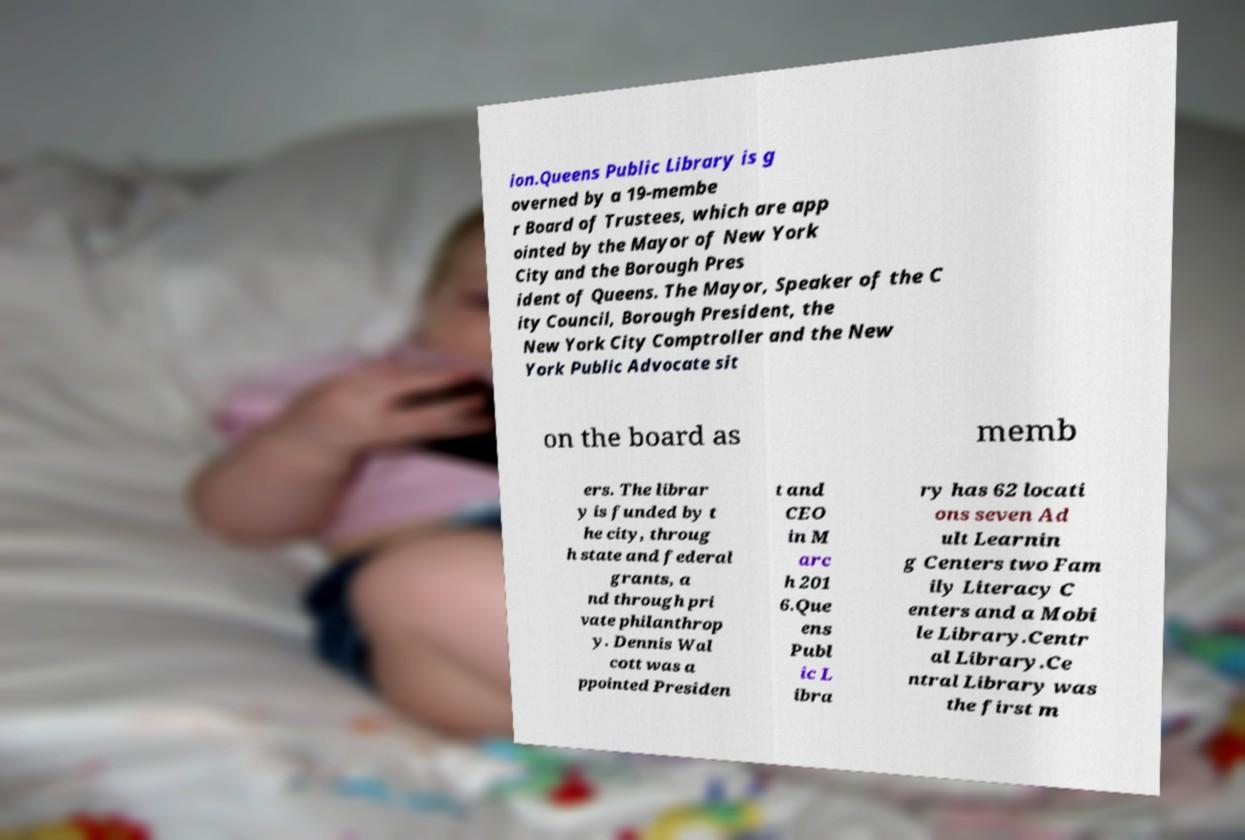Could you extract and type out the text from this image? ion.Queens Public Library is g overned by a 19-membe r Board of Trustees, which are app ointed by the Mayor of New York City and the Borough Pres ident of Queens. The Mayor, Speaker of the C ity Council, Borough President, the New York City Comptroller and the New York Public Advocate sit on the board as memb ers. The librar y is funded by t he city, throug h state and federal grants, a nd through pri vate philanthrop y. Dennis Wal cott was a ppointed Presiden t and CEO in M arc h 201 6.Que ens Publ ic L ibra ry has 62 locati ons seven Ad ult Learnin g Centers two Fam ily Literacy C enters and a Mobi le Library.Centr al Library.Ce ntral Library was the first m 